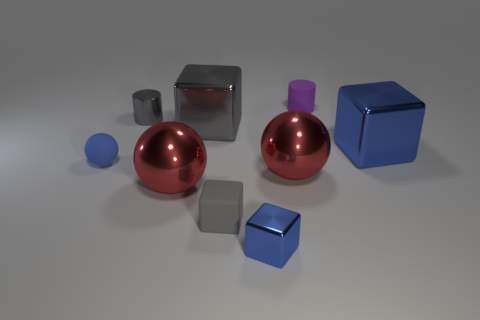What number of matte things are both on the right side of the small metallic cylinder and in front of the purple matte cylinder?
Your answer should be compact. 1. The tiny gray object that is on the right side of the tiny gray metal cylinder has what shape?
Offer a very short reply. Cube. How many metallic things have the same size as the metallic cylinder?
Your response must be concise. 1. There is a large shiny cube to the right of the purple cylinder; does it have the same color as the matte sphere?
Make the answer very short. Yes. What material is the big thing that is both in front of the large blue cube and right of the small blue shiny block?
Give a very brief answer. Metal. Are there more matte balls than big shiny objects?
Offer a very short reply. No. What color is the cylinder right of the gray object that is in front of the big thing that is right of the small purple matte cylinder?
Keep it short and to the point. Purple. Is the cube that is to the right of the tiny purple matte thing made of the same material as the large gray object?
Your response must be concise. Yes. Are there any large metal objects of the same color as the small metallic cylinder?
Offer a terse response. Yes. Are there any big rubber spheres?
Your answer should be compact. No. 